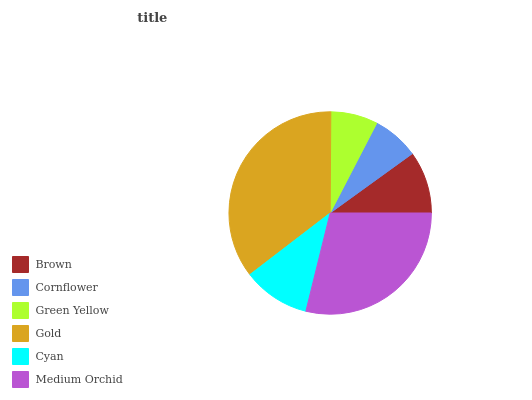Is Cornflower the minimum?
Answer yes or no. Yes. Is Gold the maximum?
Answer yes or no. Yes. Is Green Yellow the minimum?
Answer yes or no. No. Is Green Yellow the maximum?
Answer yes or no. No. Is Green Yellow greater than Cornflower?
Answer yes or no. Yes. Is Cornflower less than Green Yellow?
Answer yes or no. Yes. Is Cornflower greater than Green Yellow?
Answer yes or no. No. Is Green Yellow less than Cornflower?
Answer yes or no. No. Is Cyan the high median?
Answer yes or no. Yes. Is Brown the low median?
Answer yes or no. Yes. Is Brown the high median?
Answer yes or no. No. Is Gold the low median?
Answer yes or no. No. 